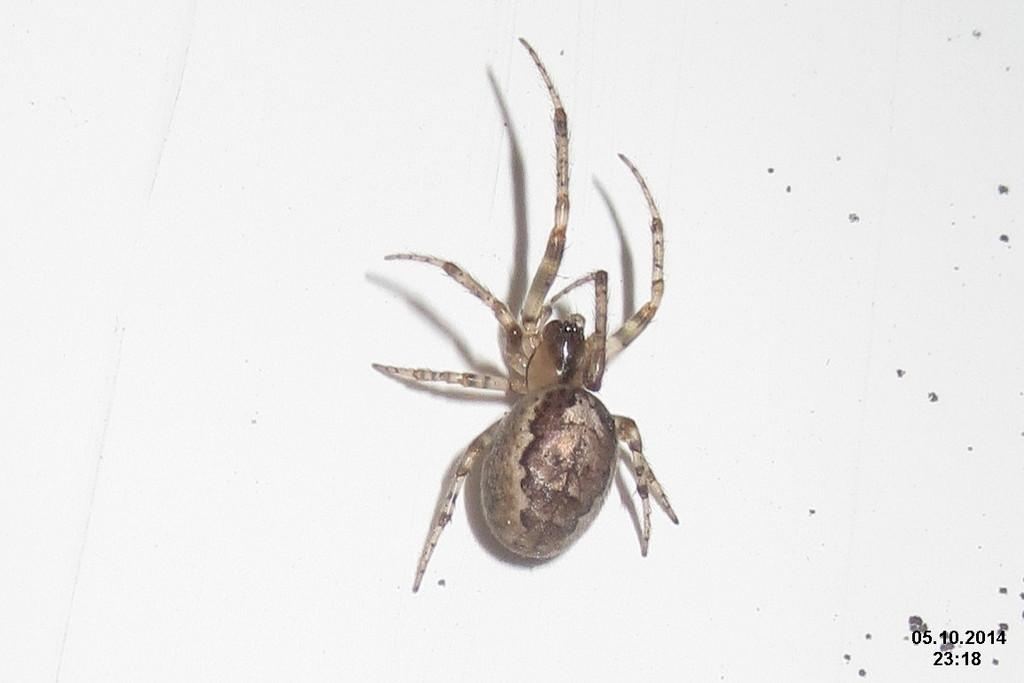What is the main subject of the image? There is a spider in the image. Where is the spider located? The spider is on a surface. Is there any text or logo visible in the image? Yes, there is a watermark in the bottom right corner of the image. What color is the background of the image? The background of the image is white. What type of orange is being held by the spider in the image? There is no orange present in the image; the main subject is a spider on a surface. 